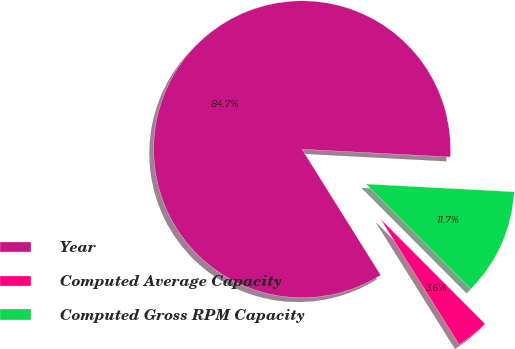Convert chart to OTSL. <chart><loc_0><loc_0><loc_500><loc_500><pie_chart><fcel>Year<fcel>Computed Average Capacity<fcel>Computed Gross RPM Capacity<nl><fcel>84.73%<fcel>3.58%<fcel>11.69%<nl></chart> 